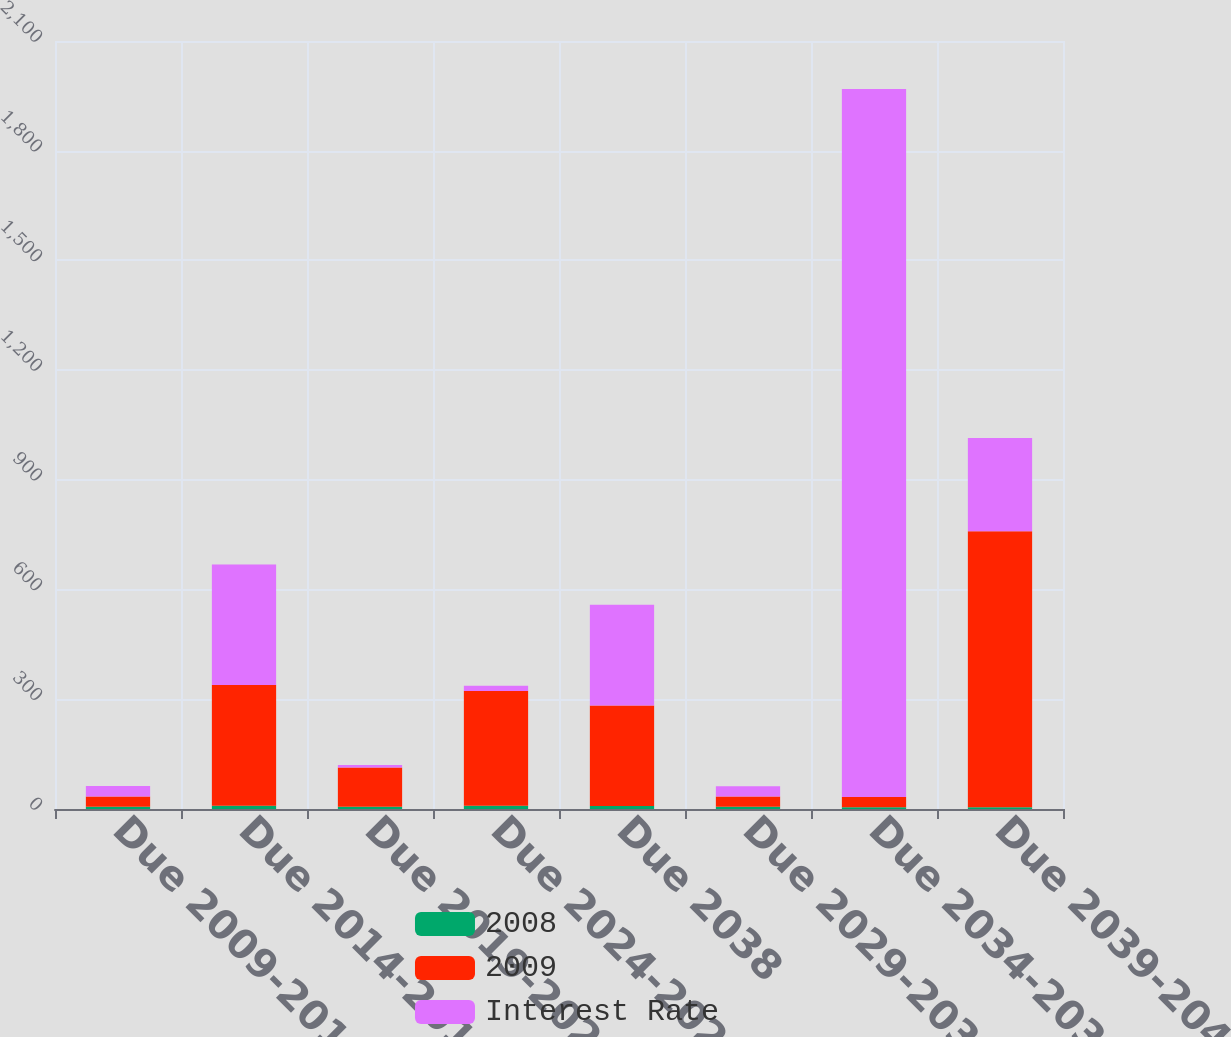Convert chart to OTSL. <chart><loc_0><loc_0><loc_500><loc_500><stacked_bar_chart><ecel><fcel>Due 2009-2013<fcel>Due 2014-2018<fcel>Due 2019-2023<fcel>Due 2024-2028<fcel>Due 2038<fcel>Due 2029-2033<fcel>Due 2034-2038<fcel>Due 2039-2043<nl><fcel>2008<fcel>5.96<fcel>8.84<fcel>6.22<fcel>8.75<fcel>8.25<fcel>6.18<fcel>4.99<fcel>4.7<nl><fcel>2009<fcel>28<fcel>330<fcel>107<fcel>314<fcel>275<fcel>28<fcel>28<fcel>755<nl><fcel>Interest Rate<fcel>29<fcel>330<fcel>7<fcel>14<fcel>275<fcel>28<fcel>1936<fcel>255<nl></chart> 